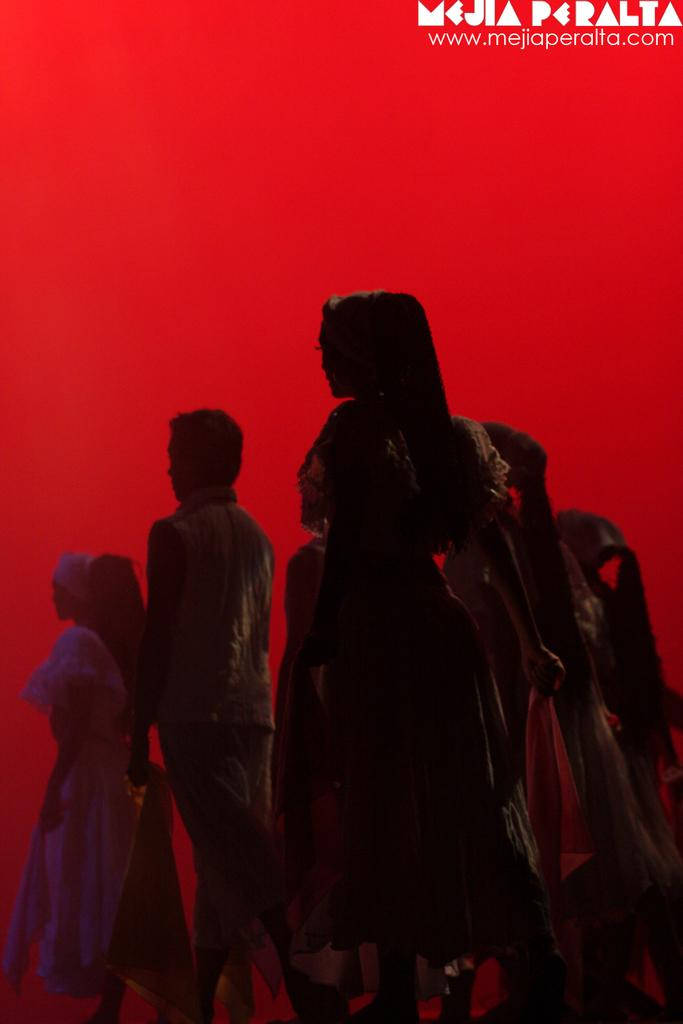What is the main object in the image? There is a poster in the image. What can be seen on the poster? The poster contains persons standing on the floor. Are there any additional elements on the poster? Yes, there is a watermark and text in the right top corner of the poster. What is the color of the background on the poster? The background of the poster is red. Can you tell me how many turkeys are swimming in the image? There are no turkeys or swimming activities present in the image; it features a poster with persons standing on the floor. 